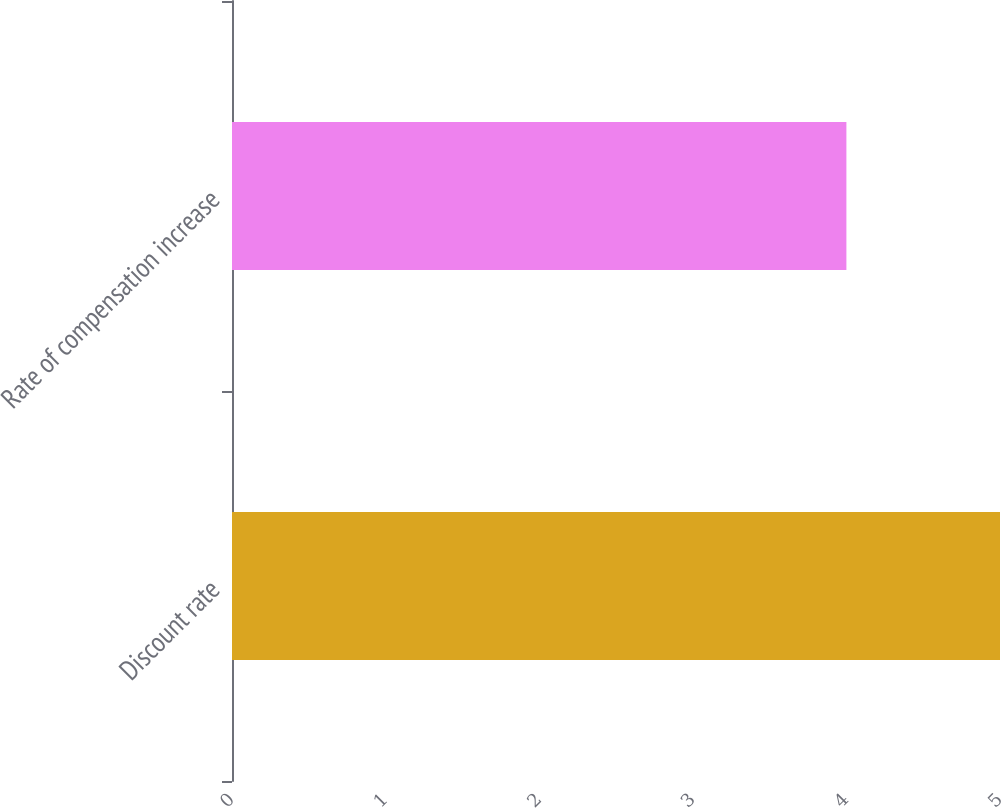Convert chart. <chart><loc_0><loc_0><loc_500><loc_500><bar_chart><fcel>Discount rate<fcel>Rate of compensation increase<nl><fcel>5<fcel>4<nl></chart> 